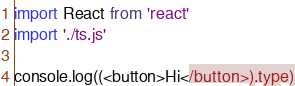Convert code to text. <code><loc_0><loc_0><loc_500><loc_500><_TypeScript_>import React from 'react'
import './ts.js'

console.log((<button>Hi</button>).type)
</code> 